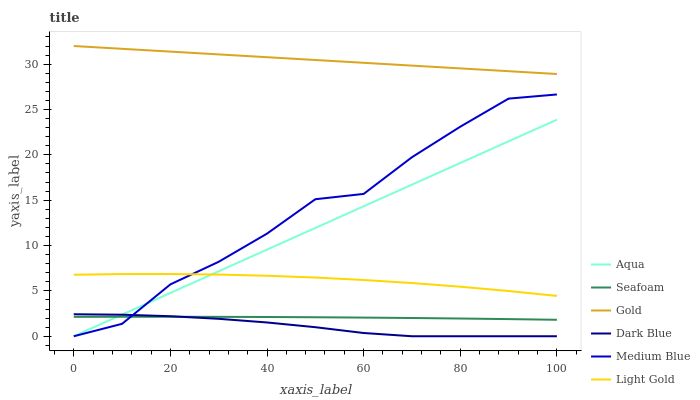Does Aqua have the minimum area under the curve?
Answer yes or no. No. Does Aqua have the maximum area under the curve?
Answer yes or no. No. Is Medium Blue the smoothest?
Answer yes or no. No. Is Aqua the roughest?
Answer yes or no. No. Does Seafoam have the lowest value?
Answer yes or no. No. Does Aqua have the highest value?
Answer yes or no. No. Is Light Gold less than Gold?
Answer yes or no. Yes. Is Gold greater than Seafoam?
Answer yes or no. Yes. Does Light Gold intersect Gold?
Answer yes or no. No. 